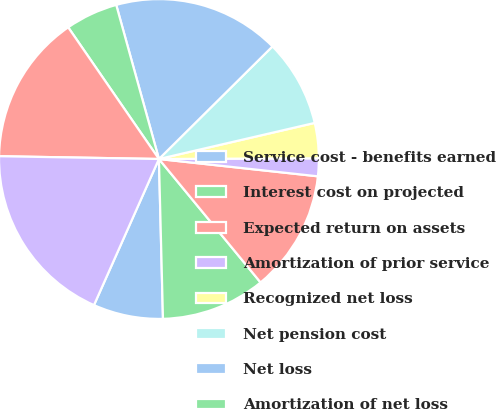Convert chart to OTSL. <chart><loc_0><loc_0><loc_500><loc_500><pie_chart><fcel>Service cost - benefits earned<fcel>Interest cost on projected<fcel>Expected return on assets<fcel>Amortization of prior service<fcel>Recognized net loss<fcel>Net pension cost<fcel>Net loss<fcel>Amortization of net loss<fcel>Total<fcel>Total recognized as net<nl><fcel>7.06%<fcel>10.56%<fcel>12.31%<fcel>1.8%<fcel>3.55%<fcel>8.81%<fcel>16.87%<fcel>5.3%<fcel>15.12%<fcel>18.62%<nl></chart> 